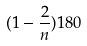<formula> <loc_0><loc_0><loc_500><loc_500>( 1 - \frac { 2 } { n } ) 1 8 0</formula> 